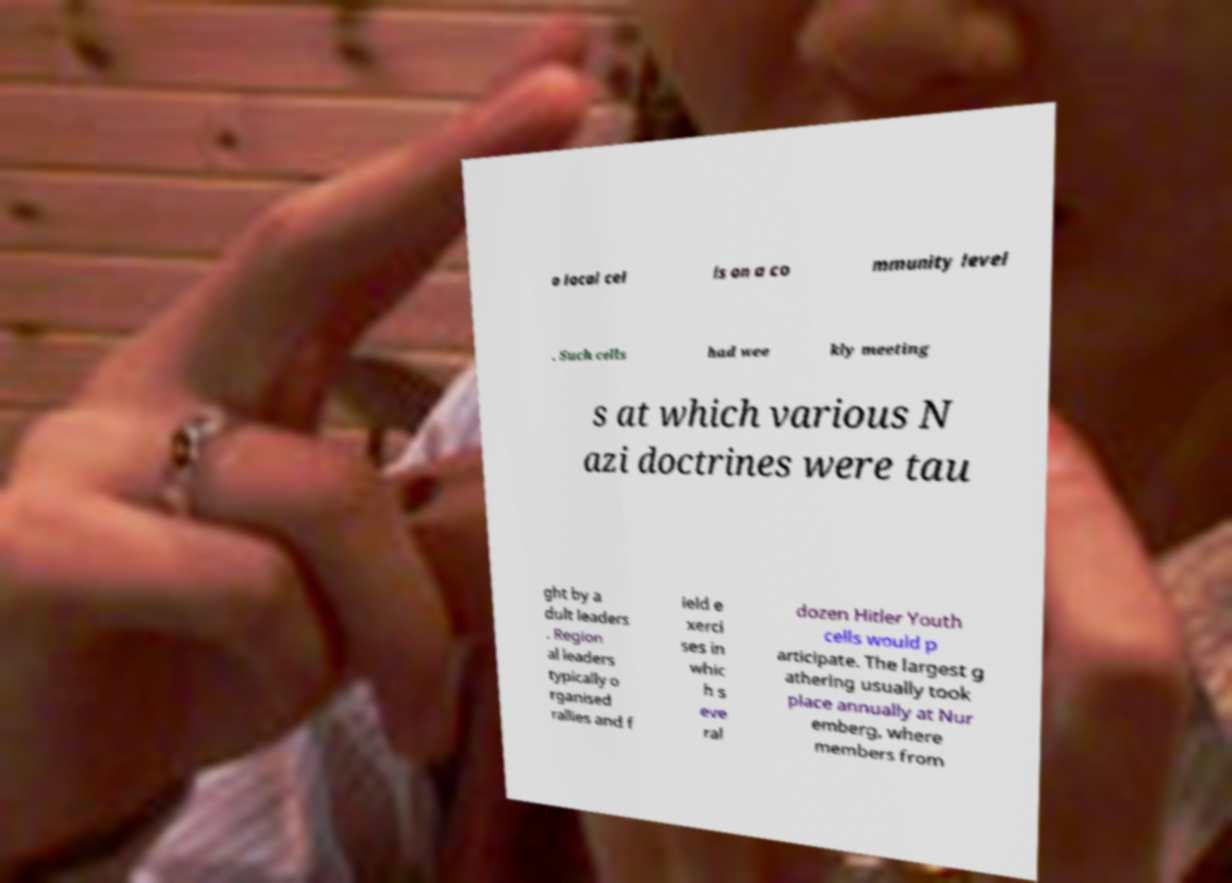I need the written content from this picture converted into text. Can you do that? o local cel ls on a co mmunity level . Such cells had wee kly meeting s at which various N azi doctrines were tau ght by a dult leaders . Region al leaders typically o rganised rallies and f ield e xerci ses in whic h s eve ral dozen Hitler Youth cells would p articipate. The largest g athering usually took place annually at Nur emberg, where members from 